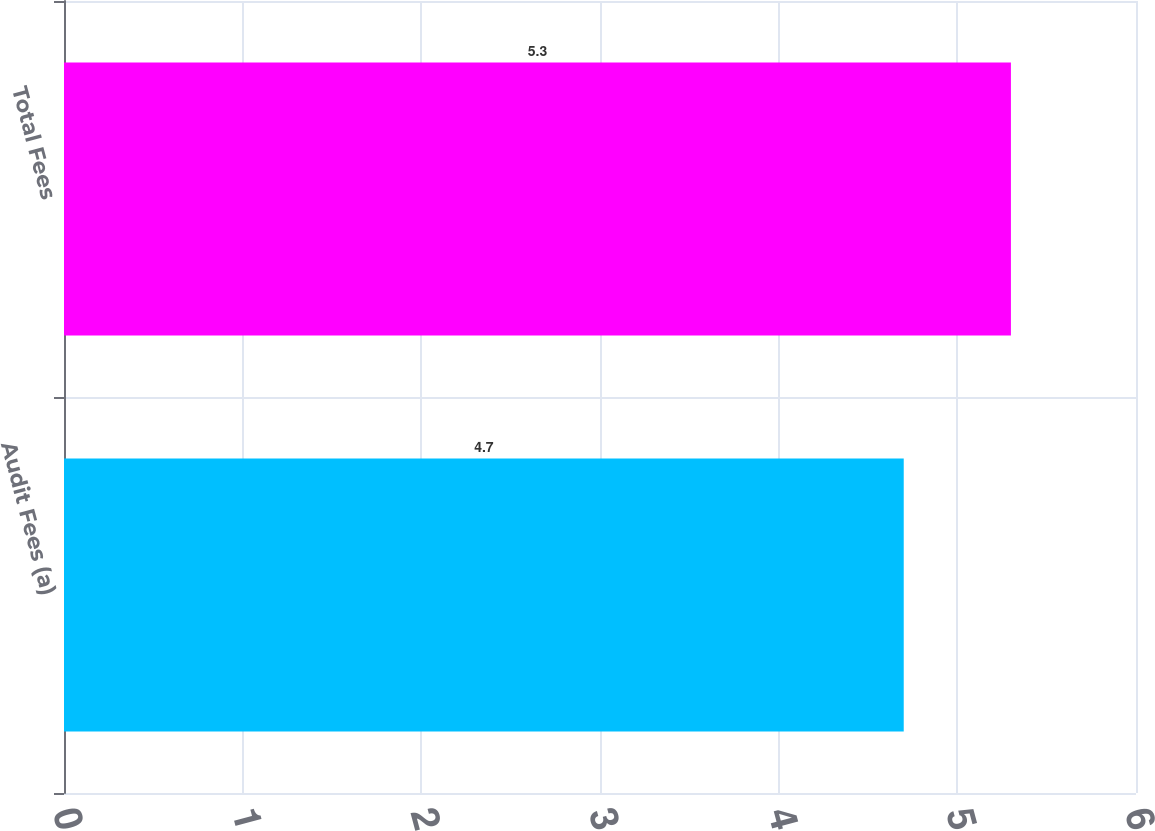Convert chart to OTSL. <chart><loc_0><loc_0><loc_500><loc_500><bar_chart><fcel>Audit Fees (a)<fcel>Total Fees<nl><fcel>4.7<fcel>5.3<nl></chart> 